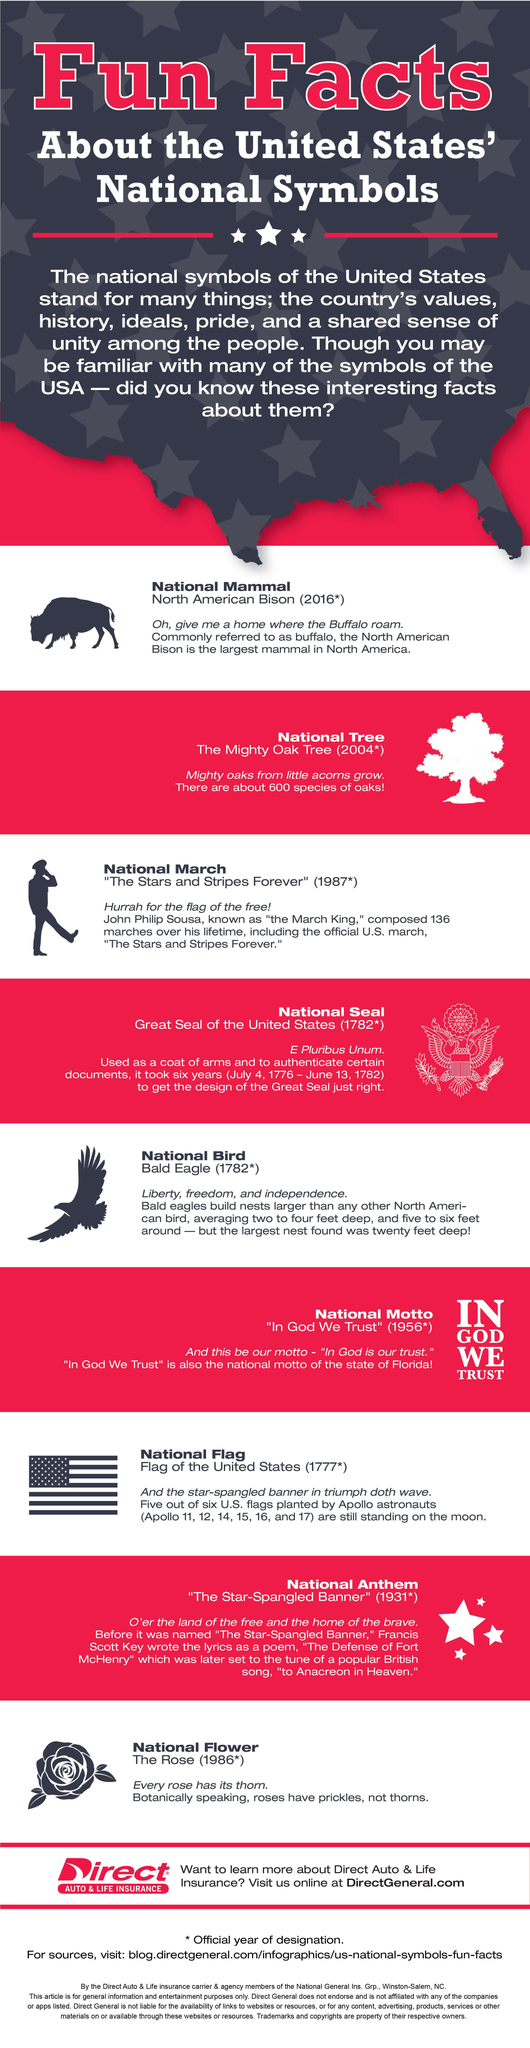what is the bison also called
Answer the question with a short phrase. buffalo which symbol was finalised first national flag which symbol was finalised the last national mammal what symbol was finalised before the national tree national march which flags are still there on the moon Apollo 11, 12, 14, 15, 16, and 17 how many symbols were finalised in 1782 2 